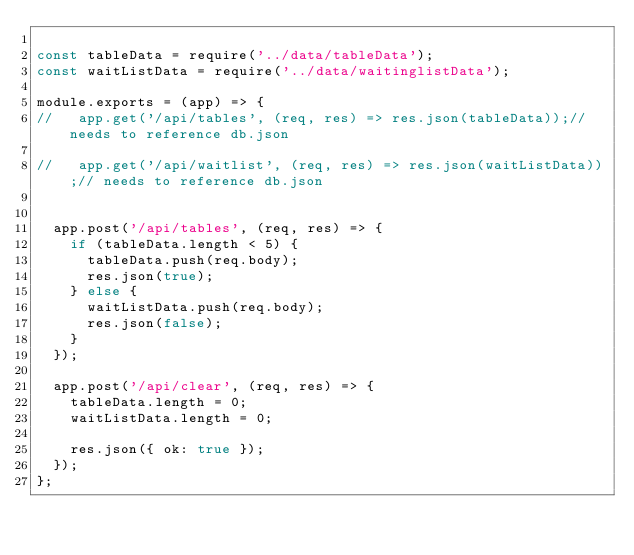<code> <loc_0><loc_0><loc_500><loc_500><_JavaScript_>
const tableData = require('../data/tableData');
const waitListData = require('../data/waitinglistData');

module.exports = (app) => {
//   app.get('/api/tables', (req, res) => res.json(tableData));// needs to reference db.json

//   app.get('/api/waitlist', (req, res) => res.json(waitListData));// needs to reference db.json


  app.post('/api/tables', (req, res) => {
    if (tableData.length < 5) {
      tableData.push(req.body);
      res.json(true);
    } else {
      waitListData.push(req.body);
      res.json(false);
    }
  });

  app.post('/api/clear', (req, res) => {
    tableData.length = 0;
    waitListData.length = 0;

    res.json({ ok: true });
  });
};
</code> 